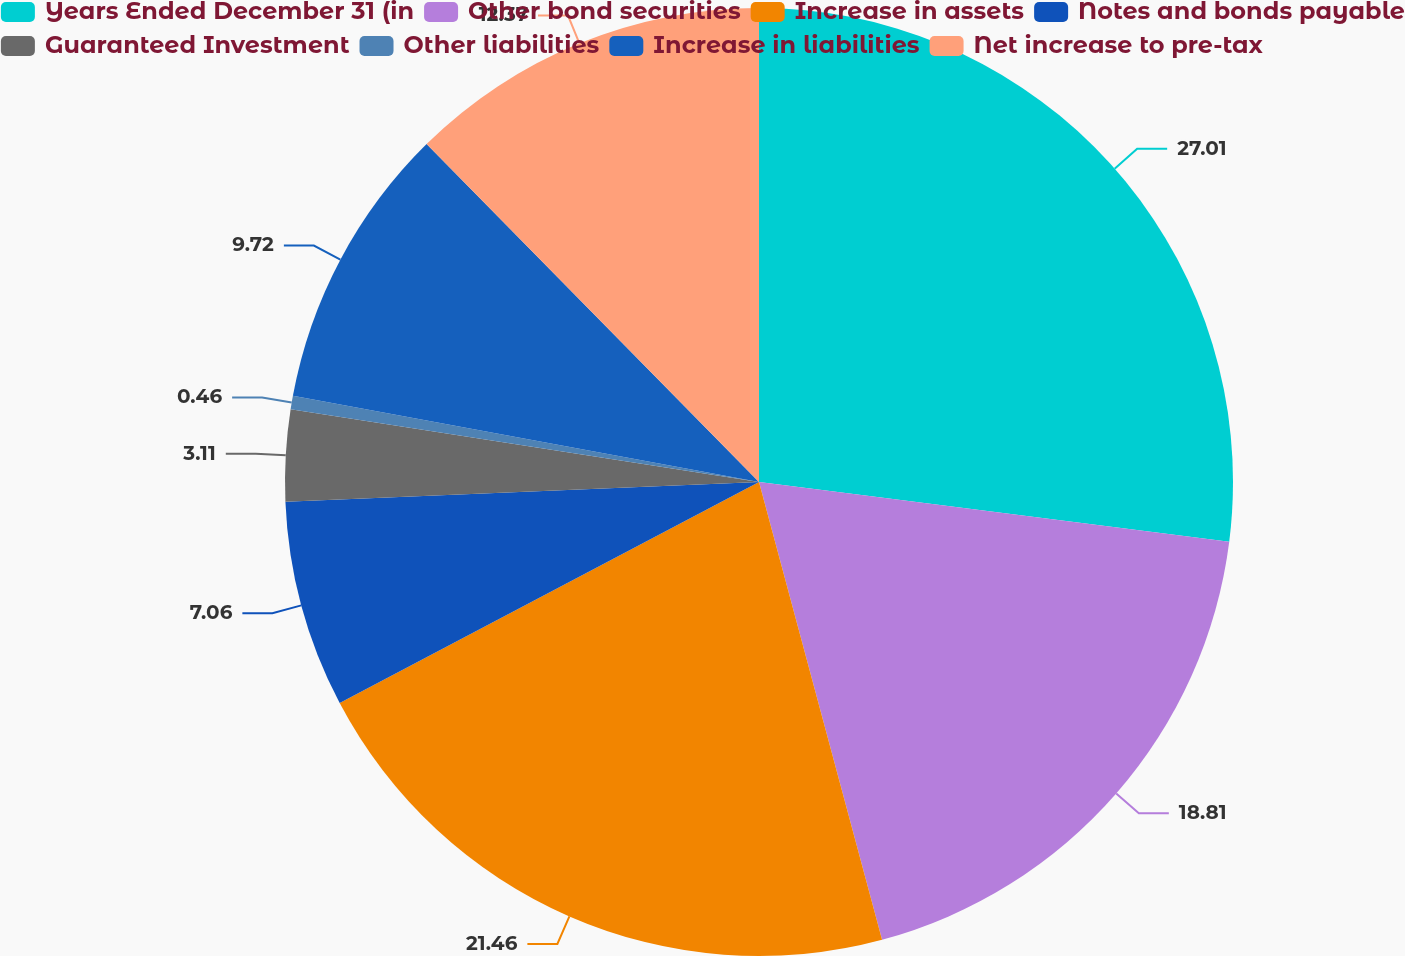Convert chart to OTSL. <chart><loc_0><loc_0><loc_500><loc_500><pie_chart><fcel>Years Ended December 31 (in<fcel>Other bond securities<fcel>Increase in assets<fcel>Notes and bonds payable<fcel>Guaranteed Investment<fcel>Other liabilities<fcel>Increase in liabilities<fcel>Net increase to pre-tax<nl><fcel>27.01%<fcel>18.81%<fcel>21.46%<fcel>7.06%<fcel>3.11%<fcel>0.46%<fcel>9.72%<fcel>12.37%<nl></chart> 